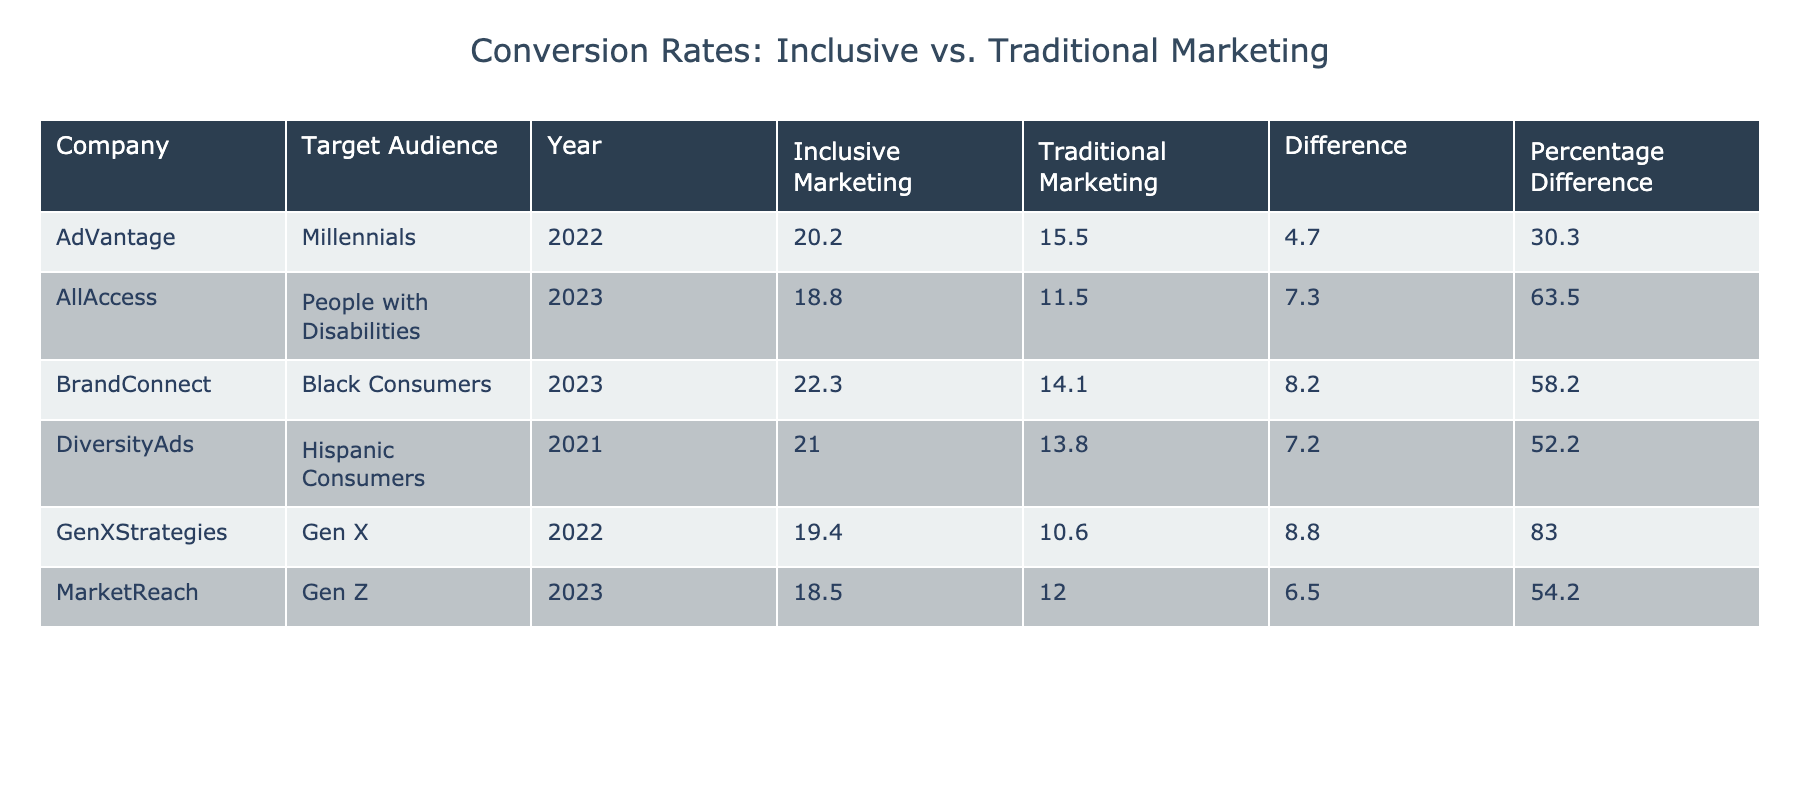What is the highest conversion rate recorded in the table? The highest conversion rate is found in the row for BrandConnect with Inclusive Marketing, which shows a conversion rate of 22.3%.
Answer: 22.3 What is the difference in conversion rates between Inclusive Marketing and Traditional Marketing for MarketReach? For MarketReach, the conversion rate for Inclusive Marketing is 18.5% and for Traditional Marketing is 12.0%. The difference is calculated as 18.5% - 12.0% = 6.5%.
Answer: 6.5 Did DiversityAds achieve a higher conversion rate with Inclusive Marketing compared to Traditional Marketing? Yes, the conversion rate for Inclusive Marketing with DiversityAds is 21.0%, while the Traditional Marketing rate is 13.8%, indicating that Inclusive Marketing was more successful.
Answer: Yes What was the conversion rate percentage increase when switching from Traditional to Inclusive Marketing for GenXStrategies? For GenXStrategies, the conversion rate for Inclusive Marketing is 19.4% and for Traditional Marketing is 10.6%. The percentage increase is calculated as ((19.4 - 10.6) / 10.6) * 100 = 83.0%.
Answer: 83.0 Which target audience had the lowest conversion rate for Inclusive Marketing? The target audience with the lowest conversion rate for Inclusive Marketing is Gen Z at 18.5%.
Answer: 18.5 What is the average conversion rate for Traditional Marketing across all companies? The Traditional Marketing conversion rates are 12.0% (MarketReach), 15.5% (AdVantage), 14.1% (BrandConnect), 13.8% (DiversityAds), 10.6% (GenXStrategies), and 11.5% (AllAccess). Summing these gives a total of 77.5%, and with 5 companies, the average is 77.5%/5 = 15.5%.
Answer: 15.5 Does the Inclusive Marketing strategy outperform Traditional Marketing for all target audiences listed in the table? Yes, for all target audiences listed (Gen Z, Millennials, Black Consumers, Hispanic Consumers, Gen X, and People with Disabilities), the conversion rates for Inclusive Marketing are consistently higher than those for Traditional Marketing.
Answer: Yes What was the difference in conversion rates for Black Consumers between Inclusive and Traditional Marketing? For Black Consumers, the conversion rate for Inclusive Marketing is 22.3%, while for Traditional Marketing, it is 14.1%. The difference is 22.3% - 14.1% = 8.2%.
Answer: 8.2 What is the conversion rate difference for People with Disabilities between both marketing strategies? For People with Disabilities, the conversion rate for Inclusive Marketing is 18.8% and for Traditional Marketing is 11.5%. The difference is calculated as 18.8% - 11.5% = 7.3%.
Answer: 7.3 